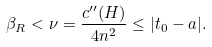<formula> <loc_0><loc_0><loc_500><loc_500>\beta _ { R } < \nu = \frac { c ^ { \prime \prime } ( H ) } { 4 n ^ { 2 } } \leq | t _ { 0 } - a | .</formula> 